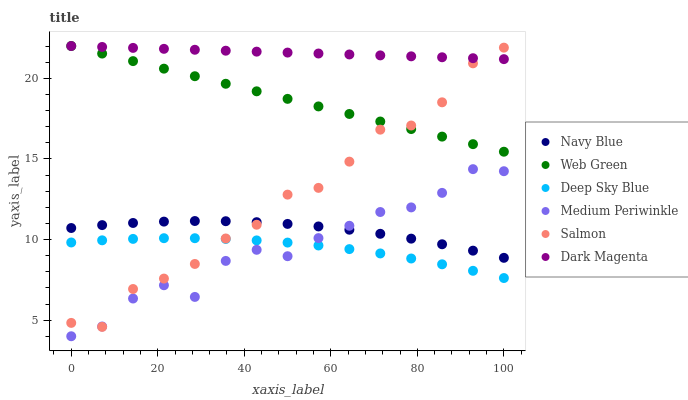Does Deep Sky Blue have the minimum area under the curve?
Answer yes or no. Yes. Does Dark Magenta have the maximum area under the curve?
Answer yes or no. Yes. Does Navy Blue have the minimum area under the curve?
Answer yes or no. No. Does Navy Blue have the maximum area under the curve?
Answer yes or no. No. Is Dark Magenta the smoothest?
Answer yes or no. Yes. Is Salmon the roughest?
Answer yes or no. Yes. Is Navy Blue the smoothest?
Answer yes or no. No. Is Navy Blue the roughest?
Answer yes or no. No. Does Medium Periwinkle have the lowest value?
Answer yes or no. Yes. Does Navy Blue have the lowest value?
Answer yes or no. No. Does Web Green have the highest value?
Answer yes or no. Yes. Does Navy Blue have the highest value?
Answer yes or no. No. Is Navy Blue less than Dark Magenta?
Answer yes or no. Yes. Is Web Green greater than Deep Sky Blue?
Answer yes or no. Yes. Does Salmon intersect Dark Magenta?
Answer yes or no. Yes. Is Salmon less than Dark Magenta?
Answer yes or no. No. Is Salmon greater than Dark Magenta?
Answer yes or no. No. Does Navy Blue intersect Dark Magenta?
Answer yes or no. No. 